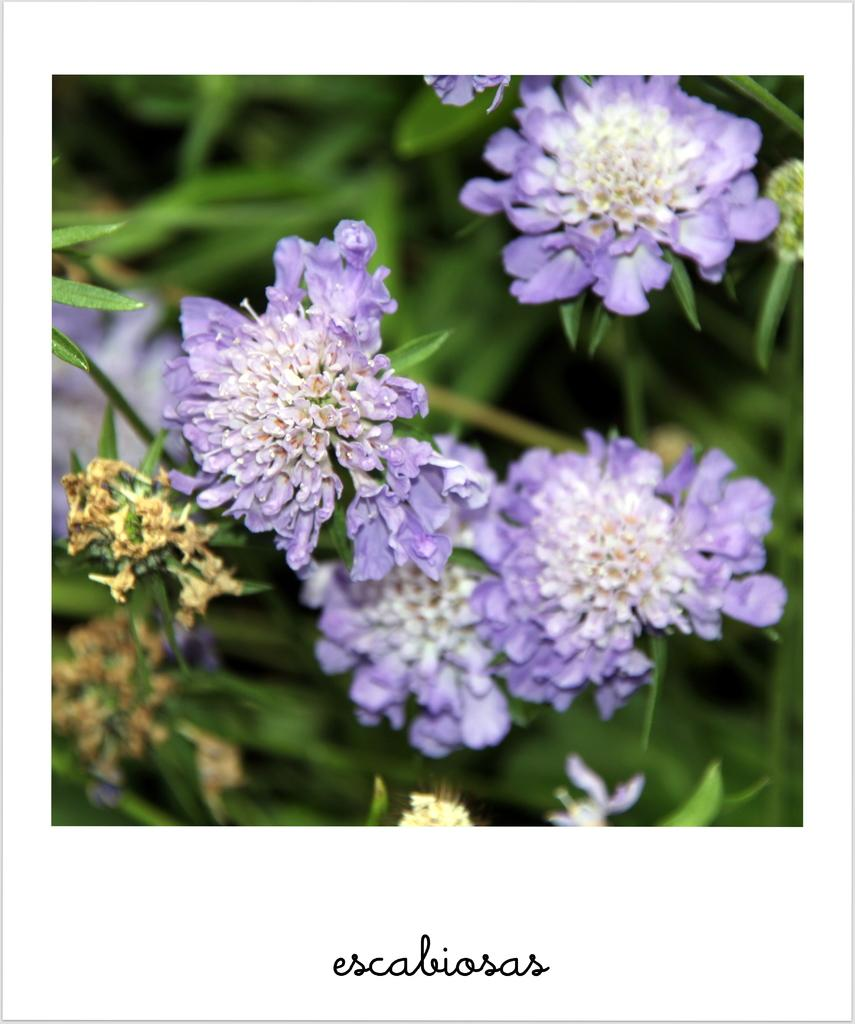What type of objects are present in the image? There are flowers in the image. Can you describe the color of the flowers? The flowers are in brinjal color. Is there any text visible in the image? Yes, there is a name in black color at the top of the image. What type of table is depicted in the image? There is no table present in the image; it features flowers and a name in black color. What type of ink is used for the name in the image? The facts do not specify the type of ink used for the name in the image, but it is mentioned that the name is in black color. 